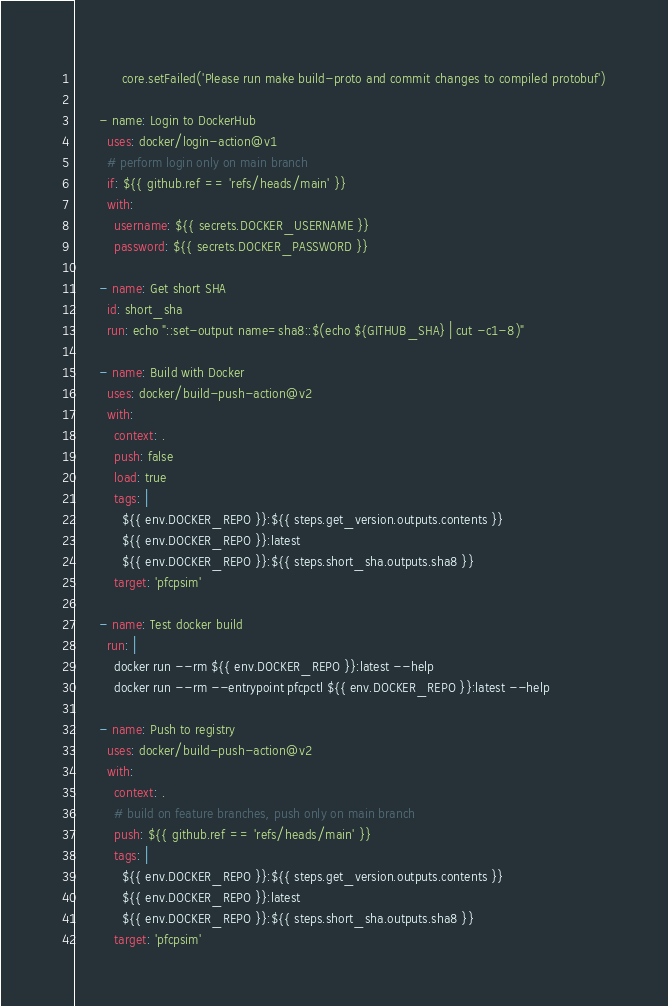Convert code to text. <code><loc_0><loc_0><loc_500><loc_500><_YAML_>            core.setFailed('Please run make build-proto and commit changes to compiled protobuf')

      - name: Login to DockerHub
        uses: docker/login-action@v1
        # perform login only on main branch
        if: ${{ github.ref == 'refs/heads/main' }}
        with:
          username: ${{ secrets.DOCKER_USERNAME }}
          password: ${{ secrets.DOCKER_PASSWORD }}

      - name: Get short SHA
        id: short_sha
        run: echo "::set-output name=sha8::$(echo ${GITHUB_SHA} | cut -c1-8)"

      - name: Build with Docker
        uses: docker/build-push-action@v2
        with:
          context: .
          push: false
          load: true
          tags: |
            ${{ env.DOCKER_REPO }}:${{ steps.get_version.outputs.contents }}
            ${{ env.DOCKER_REPO }}:latest
            ${{ env.DOCKER_REPO }}:${{ steps.short_sha.outputs.sha8 }}
          target: 'pfcpsim'

      - name: Test docker build
        run: |
          docker run --rm ${{ env.DOCKER_REPO }}:latest --help
          docker run --rm --entrypoint pfcpctl ${{ env.DOCKER_REPO }}:latest --help

      - name: Push to registry
        uses: docker/build-push-action@v2
        with:
          context: .
          # build on feature branches, push only on main branch
          push: ${{ github.ref == 'refs/heads/main' }}
          tags: |
            ${{ env.DOCKER_REPO }}:${{ steps.get_version.outputs.contents }}
            ${{ env.DOCKER_REPO }}:latest
            ${{ env.DOCKER_REPO }}:${{ steps.short_sha.outputs.sha8 }}
          target: 'pfcpsim'
</code> 